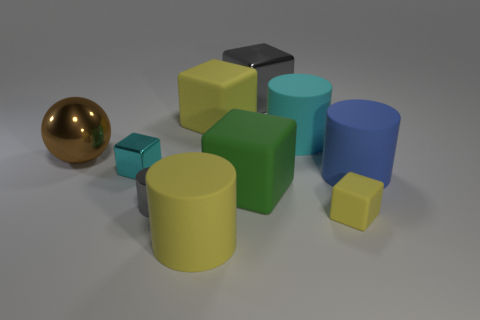There is a metallic sphere that is the same size as the cyan cylinder; what is its color?
Offer a terse response. Brown. There is a small metallic cylinder; is it the same color as the metallic block behind the cyan metal block?
Your answer should be compact. Yes. What is the material of the big thing to the left of the metallic block that is to the left of the big yellow cylinder?
Offer a very short reply. Metal. How many objects are on the right side of the large metal sphere and left of the big yellow matte cylinder?
Offer a terse response. 2. What number of other objects are there of the same size as the cyan metal block?
Make the answer very short. 2. There is a gray thing that is to the left of the big gray object; is it the same shape as the large yellow thing that is in front of the large green object?
Make the answer very short. Yes. Are there any large objects to the left of the green thing?
Offer a very short reply. Yes. What color is the small metallic thing that is the same shape as the tiny matte thing?
Offer a terse response. Cyan. Is there any other thing that is the same shape as the big brown metallic object?
Give a very brief answer. No. What is the cyan object on the left side of the big gray metallic block made of?
Provide a succinct answer. Metal. 